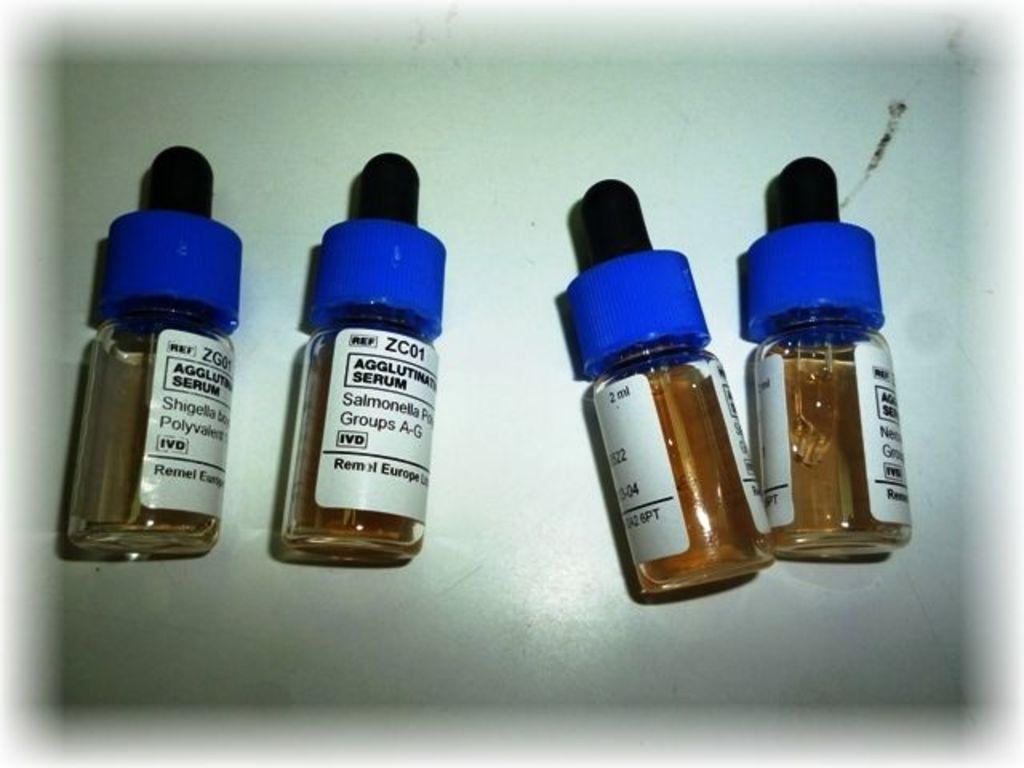Provide a one-sentence caption for the provided image. Four jars of a Serum with blue lids. 